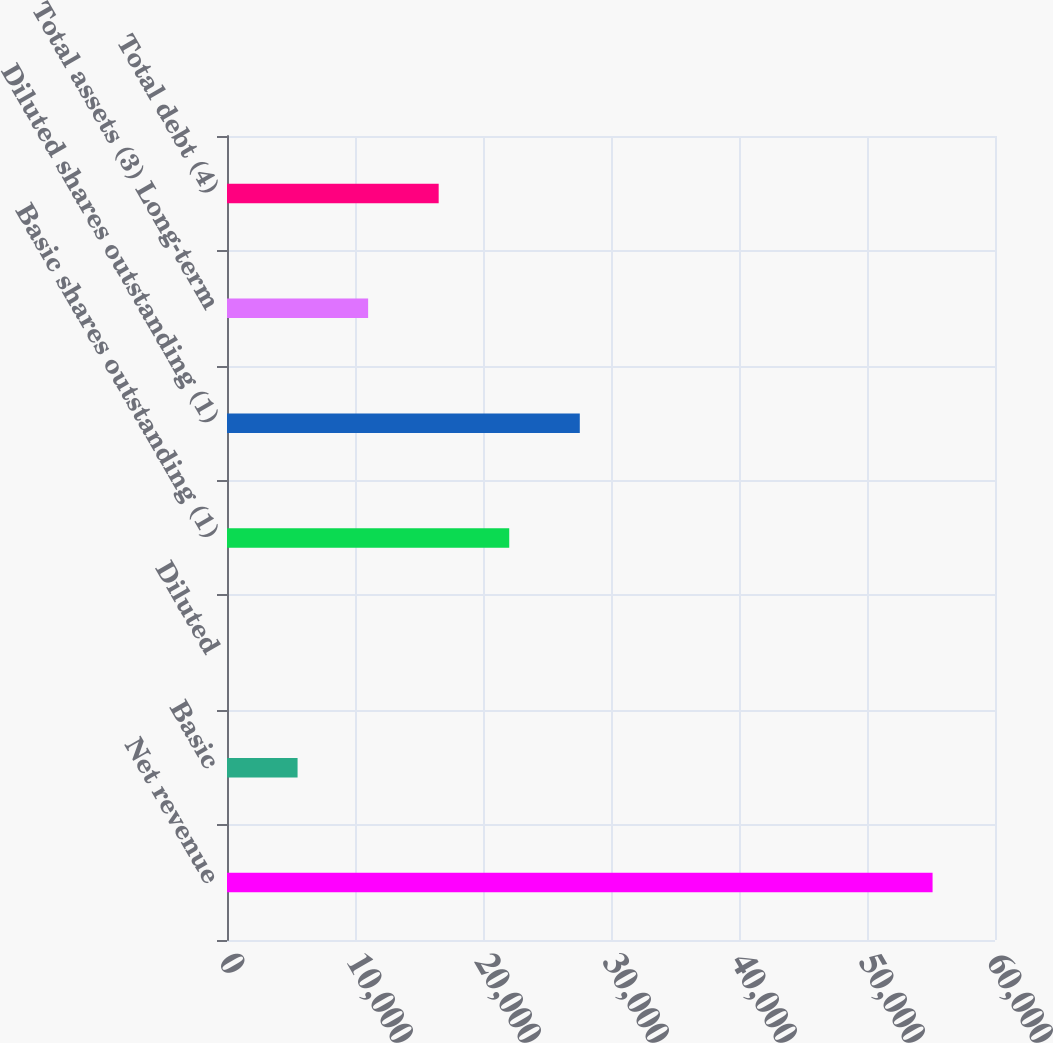Convert chart. <chart><loc_0><loc_0><loc_500><loc_500><bar_chart><fcel>Net revenue<fcel>Basic<fcel>Diluted<fcel>Basic shares outstanding (1)<fcel>Diluted shares outstanding (1)<fcel>Total assets (3) Long-term<fcel>Total debt (4)<nl><fcel>55123<fcel>5513.11<fcel>0.9<fcel>22049.7<fcel>27562<fcel>11025.3<fcel>16537.5<nl></chart> 